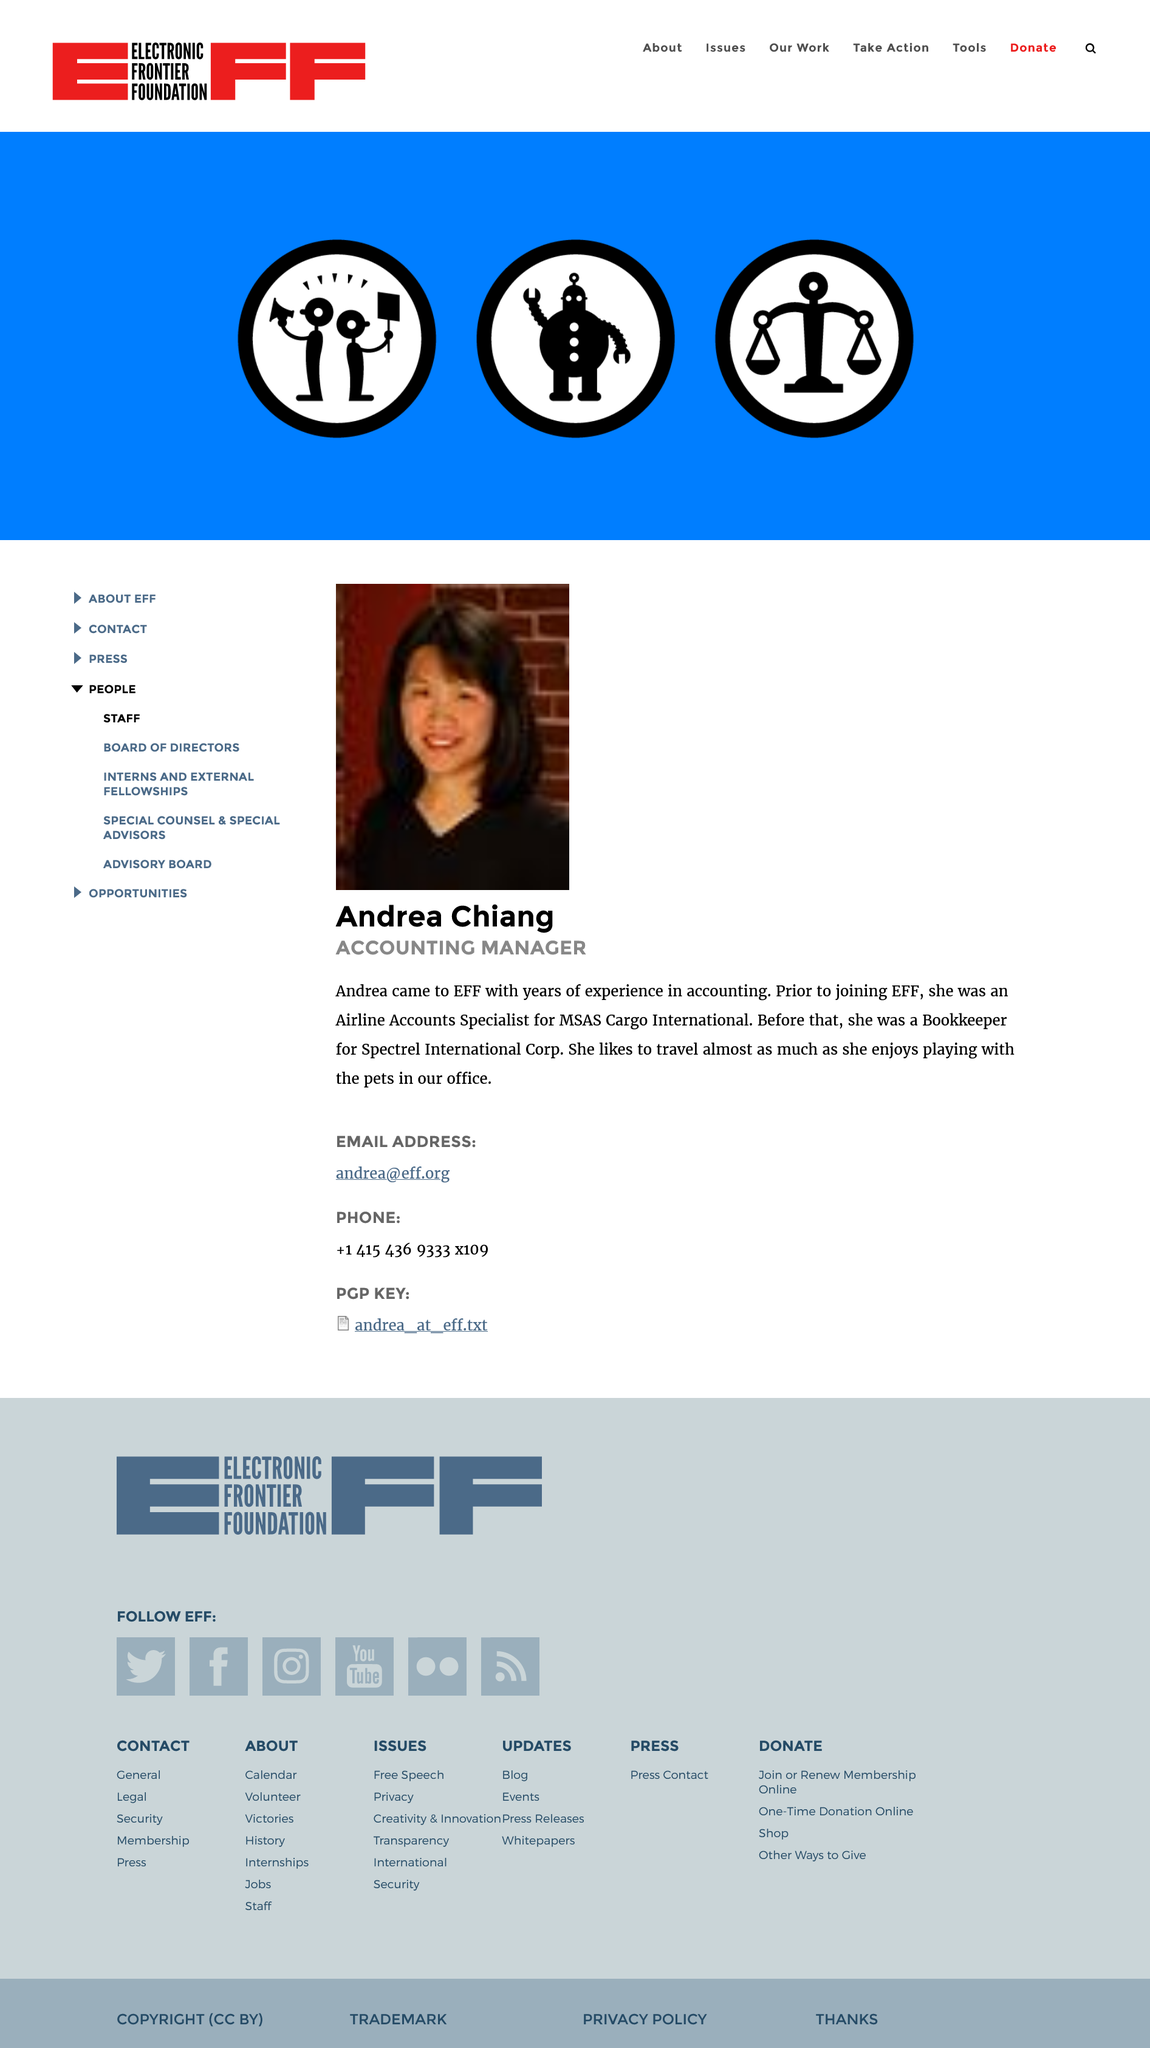List a handful of essential elements in this visual. Andrea Chiang enjoys traveling. Andrea Chiang was previously a bookkeeper. Andrea Chiang holds the position of accounting manager. 